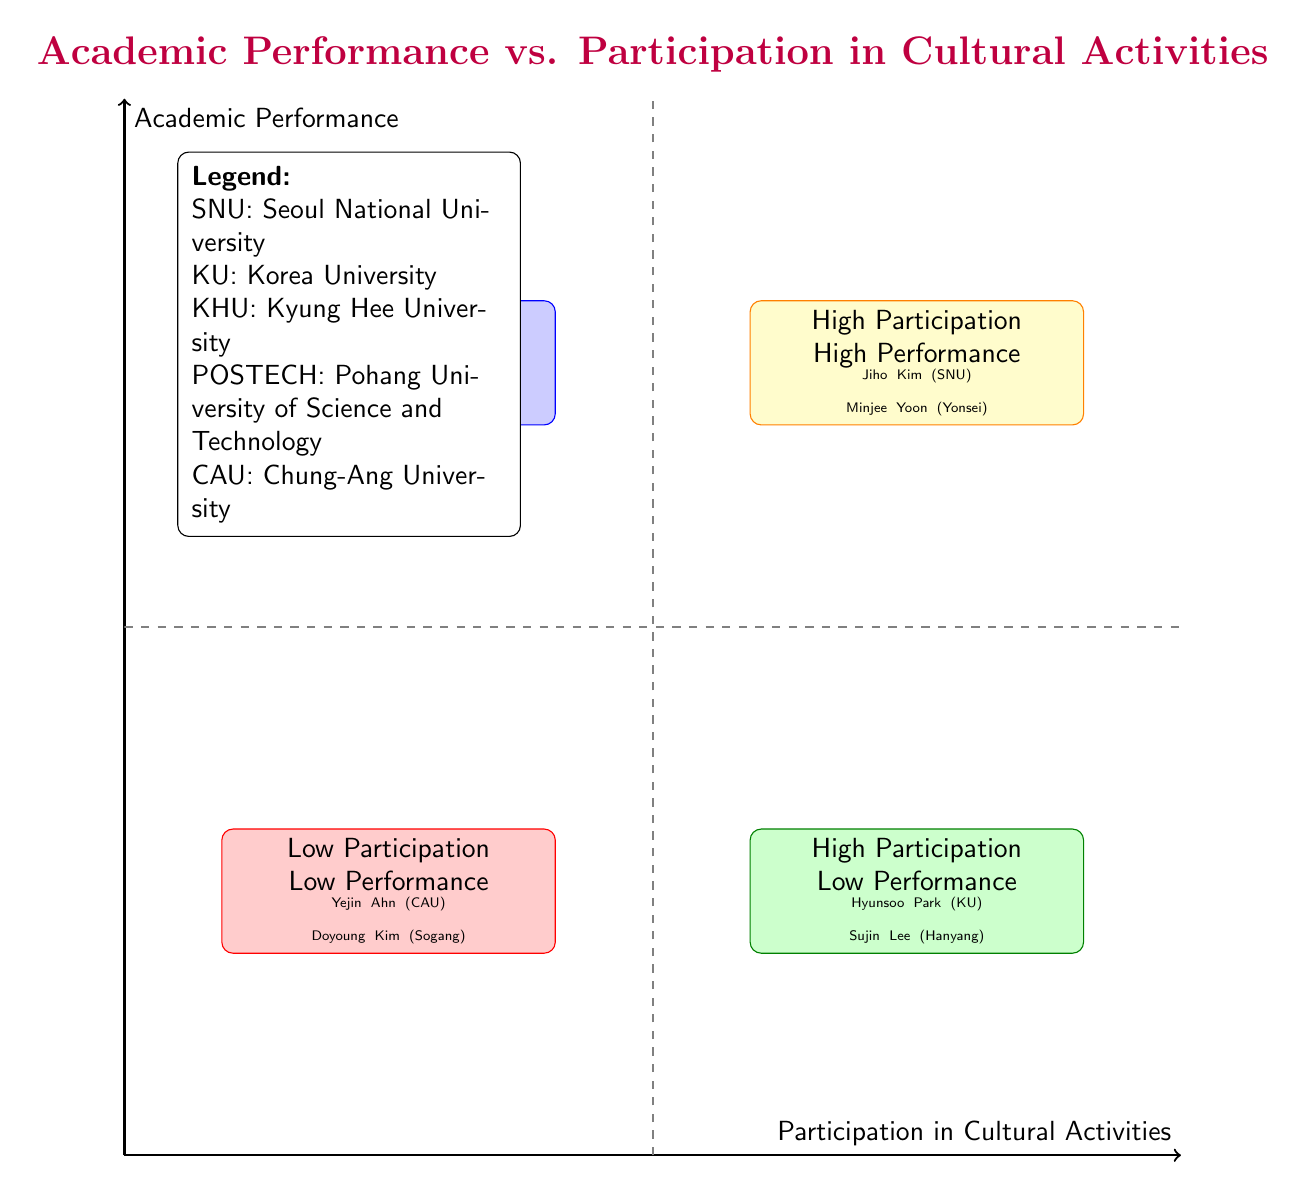What are the coordinates of Jiho Kim? Jiho Kim is located in the quadrant for High Participation and High Performance, which has coordinates approximately at (7.5, 7.5).
Answer: (7.5, 7.5) How many students have low academic performance listed in the diagram? The Low Participation Low Performance quadrant includes two students: Yejin Ahn and Doyoung Kim. Therefore, there are 2 students with low academic performance.
Answer: 2 Which university does Minjee Yoon attend? Minjee Yoon is mentioned in the High Participation High Performance quadrant, and it specifies she attends Yonsei University.
Answer: Yonsei University Which quadrant contains students with high cultural activity participation but low academic performance? The High Participation Low Performance quadrant contains students striving to participate actively in cultural activities but achieving low academic performance.
Answer: High Participation Low Performance Which student has the highest GPA? Jiho Kim, who is in the quadrant for High Participation and High Performance, has the highest GPA listed, which is 3.9.
Answer: 3.9 In which quadrant would you find students not participating in any cultural activities? Students participating in no cultural activities fall into the Low Participation Low Performance quadrant, as they don't engage in cultural activities and also show low performance.
Answer: Low Participation Low Performance How many universities are represented in the diagram? From the examples listed in each quadrant, five universities are mentioned: Seoul National University, Yonsei University, Korea University, Hanyang University, and Kyung Hee University, among others.
Answer: 5 What do the dashed lines in the diagram represent? The dashed lines indicate the boundaries separating the quadrants for participation and performance levels. The vertical line represents the divide between low and high participation, while the horizontal line separates low and high performance.
Answer: Quadrant boundaries What is the GPA range for the students participating in the High Participation High Performance quadrant? The GPA range for students in this quadrant is from 3.8 to 3.9, as listed for Jiho Kim and Minjee Yoon.
Answer: 3.8 to 3.9 